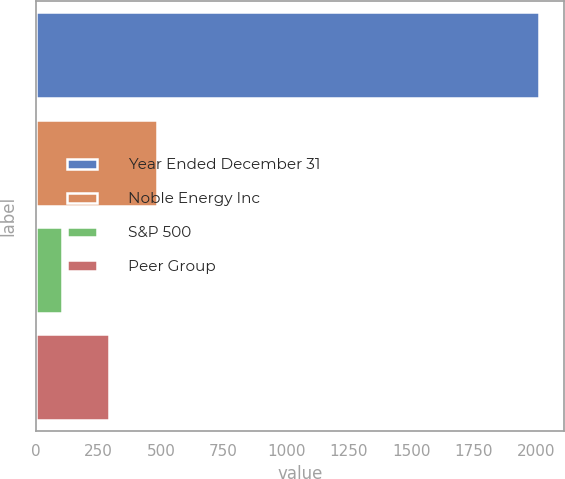<chart> <loc_0><loc_0><loc_500><loc_500><bar_chart><fcel>Year Ended December 31<fcel>Noble Energy Inc<fcel>S&P 500<fcel>Peer Group<nl><fcel>2009<fcel>483.49<fcel>102.11<fcel>292.8<nl></chart> 